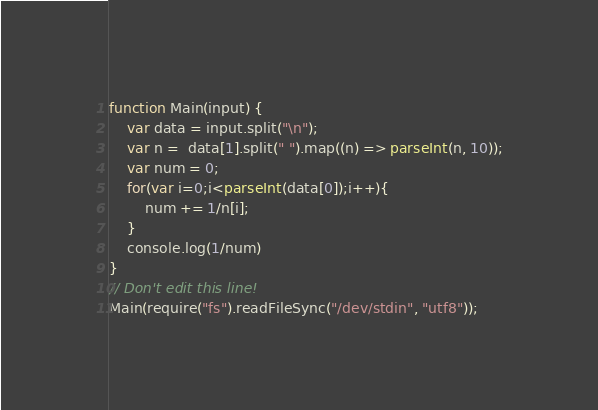Convert code to text. <code><loc_0><loc_0><loc_500><loc_500><_JavaScript_>function Main(input) {
	var data = input.split("\n");
	var n =  data[1].split(" ").map((n) => parseInt(n, 10));
	var num = 0;
	for(var i=0;i<parseInt(data[0]);i++){
		num += 1/n[i];
	}
	console.log(1/num)
}
// Don't edit this line!
Main(require("fs").readFileSync("/dev/stdin", "utf8"));</code> 